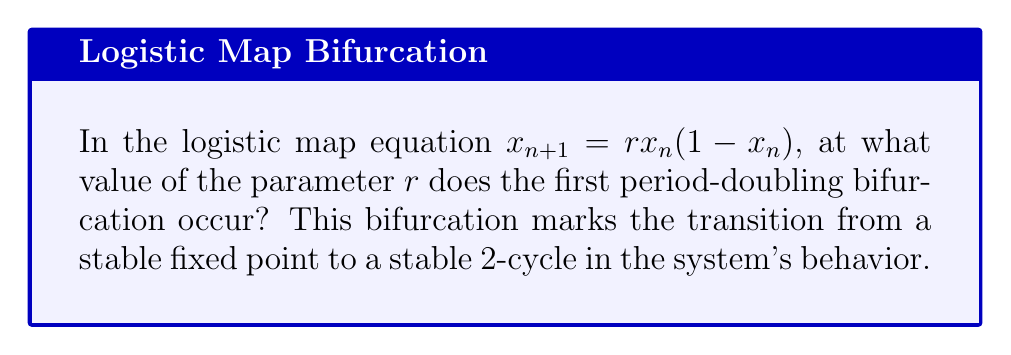Show me your answer to this math problem. To find the first period-doubling bifurcation point in the logistic map, we need to follow these steps:

1. Recall the logistic map equation: $x_{n+1} = rx_n(1-x_n)$

2. For $r < 3$, the system has a stable fixed point. We need to find when this stability changes.

3. The fixed point of the system is given by:
   $x^* = rx^*(1-x^*)$
   Solving this, we get: $x^* = 0$ or $x^* = 1 - \frac{1}{r}$ (for $r \neq 0$)

4. To determine stability, we calculate the derivative of the map at the fixed point:
   $f'(x) = r(1-2x)$

5. At the non-zero fixed point $x^* = 1 - \frac{1}{r}$, the derivative is:
   $f'(x^*) = r(1-2(1-\frac{1}{r})) = r(1-2+\frac{2}{r}) = -r+2$

6. The fixed point loses stability when $|f'(x^*)| = 1$. In this case:
   $|-r+2| = 1$

7. Solving this equation:
   $-r+2 = -1$ or $-r+2 = 1$
   $r = 3$ or $r = 1$

8. Since we're looking for the transition from stability to instability, and the system is stable for $r < 3$, the bifurcation occurs at $r = 3$.

At this point, the system transitions from a stable fixed point to a stable 2-cycle, marking the first period-doubling bifurcation in the logistic map.
Answer: $r = 3$ 